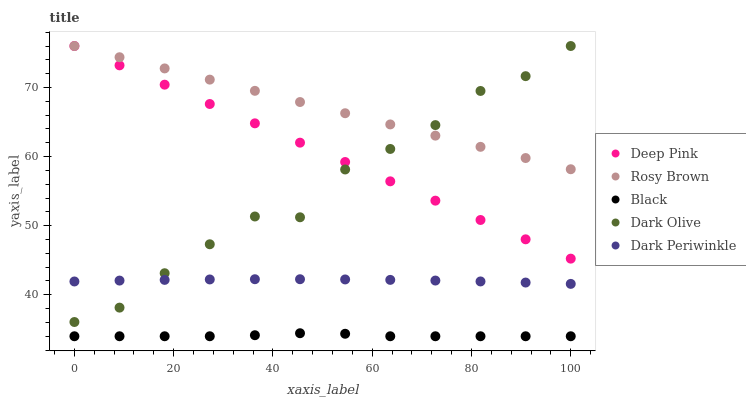Does Black have the minimum area under the curve?
Answer yes or no. Yes. Does Rosy Brown have the maximum area under the curve?
Answer yes or no. Yes. Does Deep Pink have the minimum area under the curve?
Answer yes or no. No. Does Deep Pink have the maximum area under the curve?
Answer yes or no. No. Is Deep Pink the smoothest?
Answer yes or no. Yes. Is Dark Olive the roughest?
Answer yes or no. Yes. Is Rosy Brown the smoothest?
Answer yes or no. No. Is Rosy Brown the roughest?
Answer yes or no. No. Does Black have the lowest value?
Answer yes or no. Yes. Does Deep Pink have the lowest value?
Answer yes or no. No. Does Deep Pink have the highest value?
Answer yes or no. Yes. Does Black have the highest value?
Answer yes or no. No. Is Black less than Dark Olive?
Answer yes or no. Yes. Is Deep Pink greater than Dark Periwinkle?
Answer yes or no. Yes. Does Deep Pink intersect Rosy Brown?
Answer yes or no. Yes. Is Deep Pink less than Rosy Brown?
Answer yes or no. No. Is Deep Pink greater than Rosy Brown?
Answer yes or no. No. Does Black intersect Dark Olive?
Answer yes or no. No. 